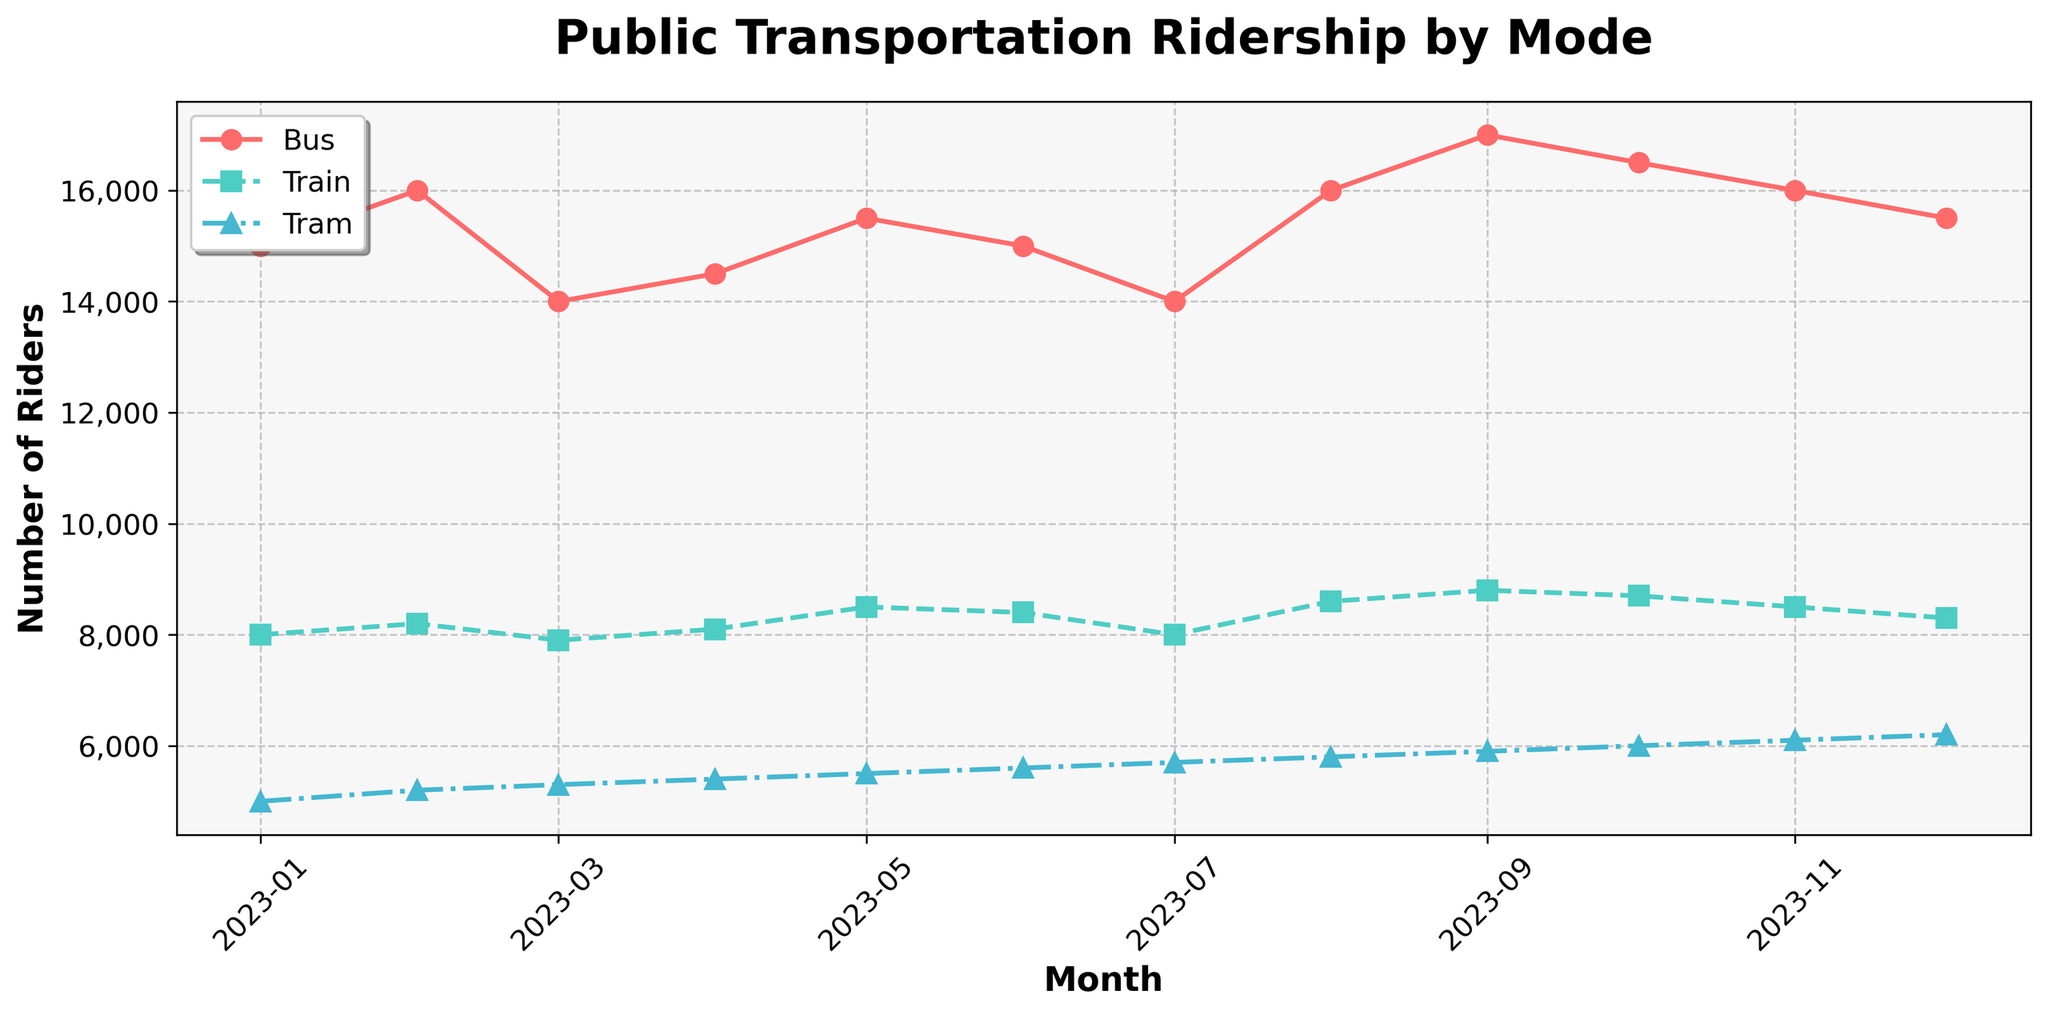What is the title of the figure? The title is displayed prominently at the top of the figure. It reads "Public Transportation Ridership by Mode".
Answer: Public Transportation Ridership by Mode What are the modes of transportation shown in the plot? By looking at the legend in the top-left corner, we can see that the modes of transportation are Bus, Train, and Tram.
Answer: Bus, Train, Tram During which month did Bus ridership peak? By examining the plot for the Bus line (red line with circles), its highest point is in September, indicating that Bus ridership peaked in September.
Answer: September What is the total ridership for all modes combined in October? To find the total, sum the ridership numbers for each mode in October: Bus (16,500) + Train (8,700) + Tram (6,000). The sum is: 16,500 + 8,700 + 6,000 = 31,200.
Answer: 31,200 Which month showed the lowest tram ridership, and what was the count? The Tram line (blue line with triangles) is at its lowest at the beginning of the year in January, where the ridership count is 5,000.
Answer: January, 5,000 How did Bus ridership change from February to March? Look at the Bus line between February and March: February (16,000) to March (14,000). The ridership decreased by 2,000.
Answer: Decreased by 2,000 Which mode of transportation had the most consistent ridership throughout the year? By comparing the fluctuations in the lines, the Train line (green line with squares) appears to have the smallest changes month-to-month, indicating the most consistent ridership.
Answer: Train Rank the monthly ridership numbers for Tram in ascending order. The Tram ridership numbers by month are: 5,000, 5,200, 5,300, 5,400, 5,500, 5,600, 5,700, 5,800, 5,900, 6,000, 6,100, 6,200. Arranged in ascending order: 5,000, 5,200, 5,300, 5,400, 5,500, 5,600, 5,700, 5,800, 5,900, 6,000, 6,100, 6,200.
Answer: 5,000, 5,200, 5,300, 5,400, 5,500, 5,600, 5,700, 5,800, 5,900, 6,000, 6,100, 6,200 Which transportation mode had the highest ridership increase from January to December? Calculate the increase for each mode: 
Bus: 15,000 (Jan) to 15,500 (Dec), increase of 500.
Train: 8,000 (Jan) to 8,300 (Dec), increase of 300.
Tram: 5,000 (Jan) to 6,200 (Dec), increase of 1,200.
The Tram had the highest increase with 1,200 riders.
Answer: Tram What was the average ridership for the Train across the entire year? To find the average, sum all monthly ridership numbers for Train and divide by 12:
(8,000 + 8,200 + 7,900 + 8,100 + 8,500 + 8,400 + 8,000 + 8,600 + 8,800 + 8,700 + 8,500 + 8,300) = 99,800, so the average is 99,800 / 12 = 8,316.67.
Answer: 8,316.67 